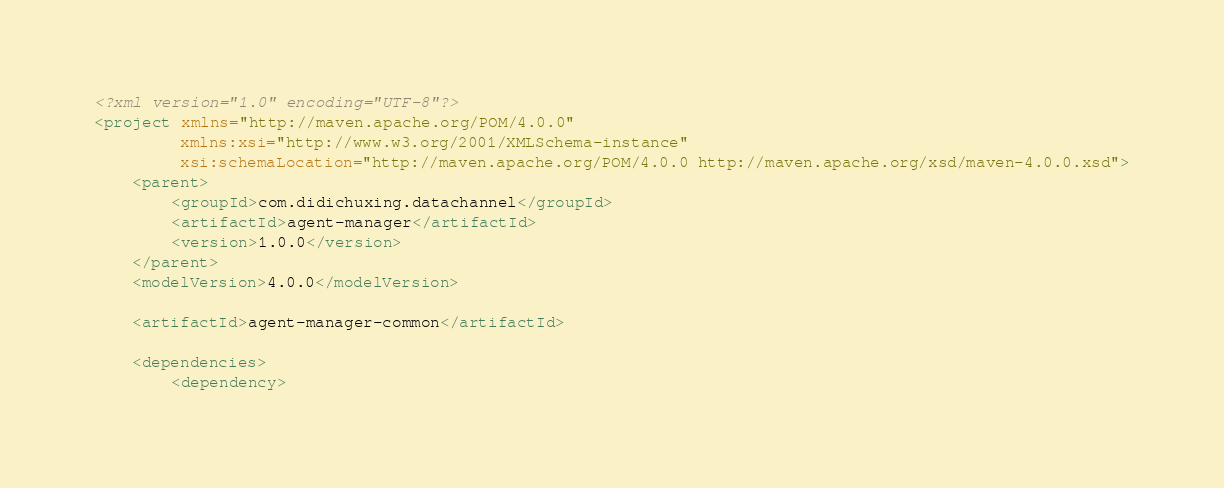<code> <loc_0><loc_0><loc_500><loc_500><_XML_><?xml version="1.0" encoding="UTF-8"?>
<project xmlns="http://maven.apache.org/POM/4.0.0"
         xmlns:xsi="http://www.w3.org/2001/XMLSchema-instance"
         xsi:schemaLocation="http://maven.apache.org/POM/4.0.0 http://maven.apache.org/xsd/maven-4.0.0.xsd">
    <parent>
        <groupId>com.didichuxing.datachannel</groupId>
        <artifactId>agent-manager</artifactId>
        <version>1.0.0</version>
    </parent>
    <modelVersion>4.0.0</modelVersion>

    <artifactId>agent-manager-common</artifactId>

    <dependencies>
        <dependency></code> 